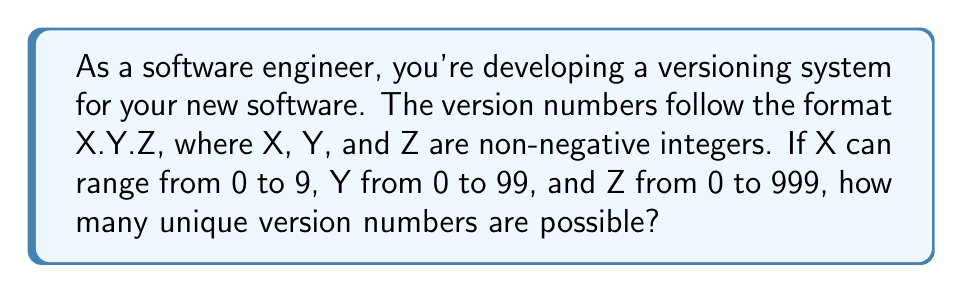Could you help me with this problem? Let's break this down step-by-step:

1) For X (major version):
   - X can be any integer from 0 to 9
   - Number of possibilities for X = 10

2) For Y (minor version):
   - Y can be any integer from 0 to 99
   - Number of possibilities for Y = 100

3) For Z (patch version):
   - Z can be any integer from 0 to 999
   - Number of possibilities for Z = 1000

4) To find the total number of unique combinations, we use the multiplication principle:
   
   $$ \text{Total combinations} = \text{Possibilities for X} \times \text{Possibilities for Y} \times \text{Possibilities for Z} $$

5) Substituting the values:

   $$ \text{Total combinations} = 10 \times 100 \times 1000 $$

6) Calculating:

   $$ \text{Total combinations} = 1,000,000 $$

Therefore, there are 1,000,000 unique version numbers possible in this system.
Answer: 1,000,000 